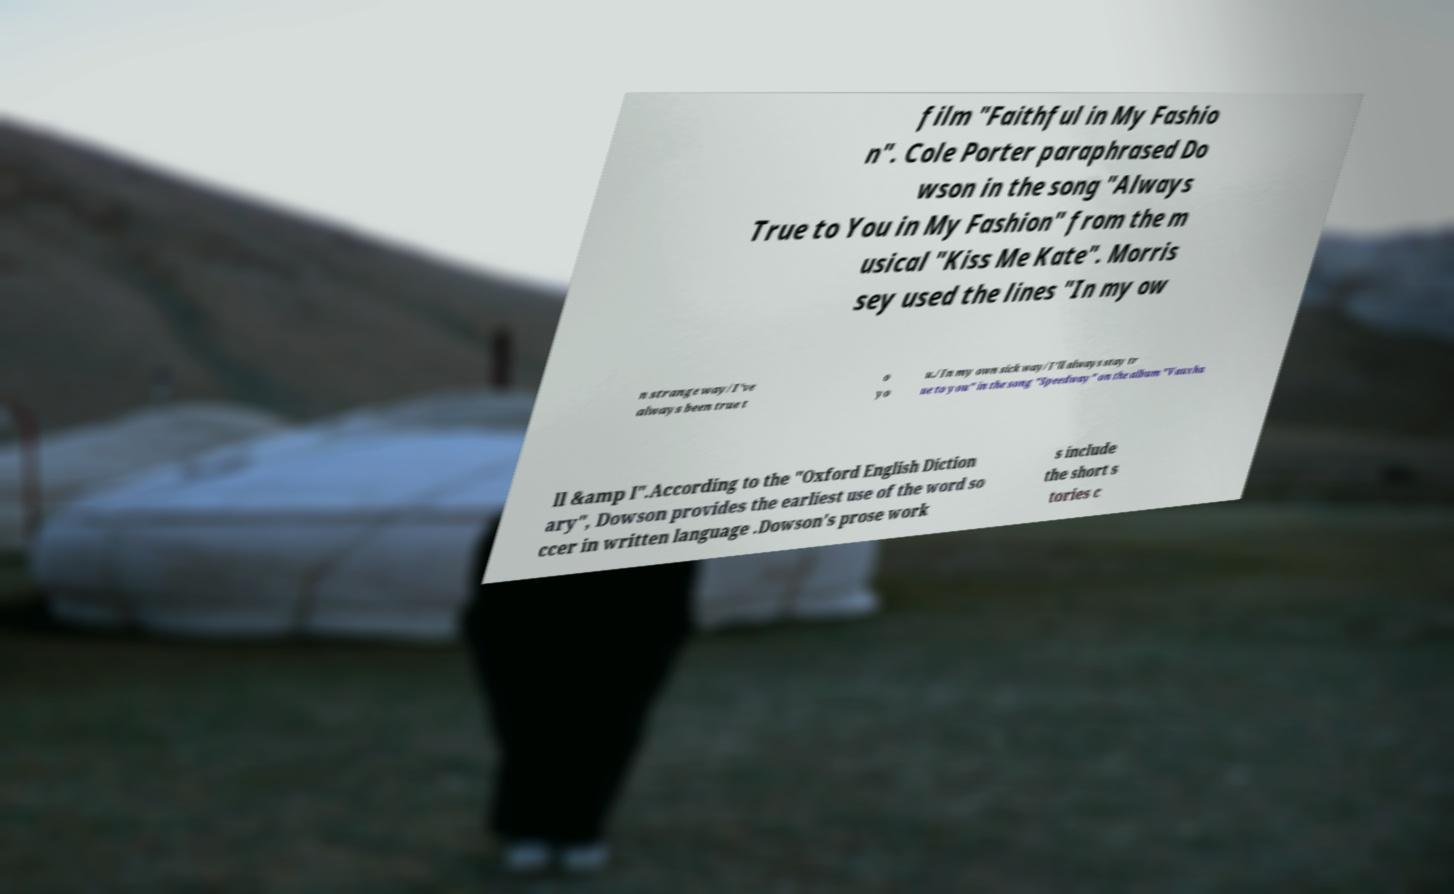There's text embedded in this image that I need extracted. Can you transcribe it verbatim? film "Faithful in My Fashio n". Cole Porter paraphrased Do wson in the song "Always True to You in My Fashion" from the m usical "Kiss Me Kate". Morris sey used the lines "In my ow n strange way/I've always been true t o yo u./In my own sick way/I'll always stay tr ue to you" in the song "Speedway" on the album "Vauxha ll &amp I".According to the "Oxford English Diction ary", Dowson provides the earliest use of the word so ccer in written language .Dowson's prose work s include the short s tories c 